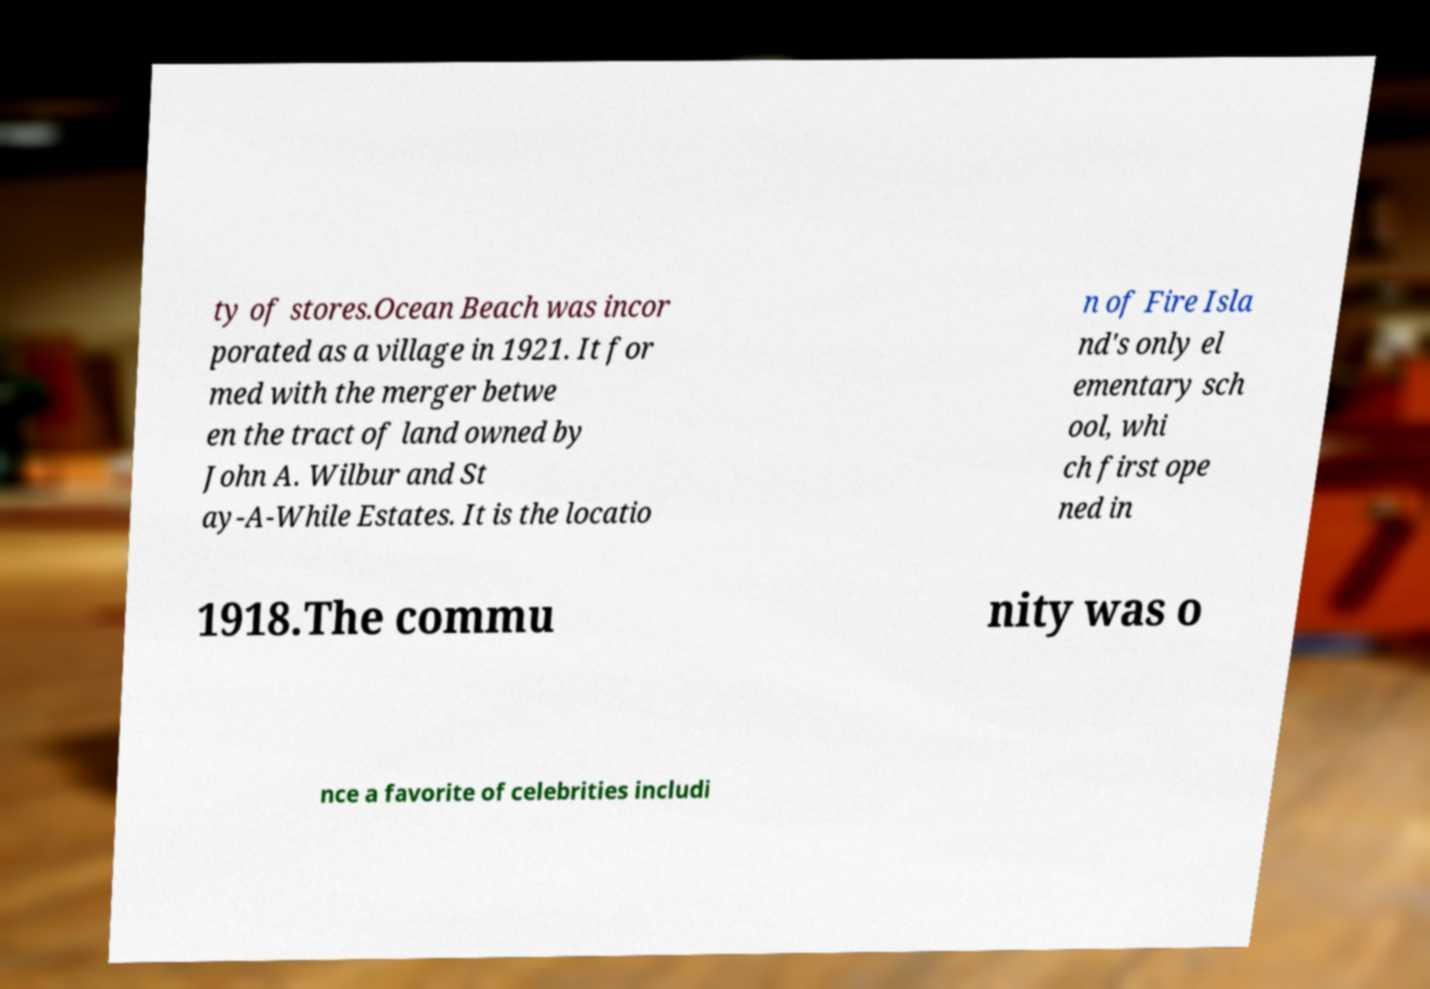Could you assist in decoding the text presented in this image and type it out clearly? ty of stores.Ocean Beach was incor porated as a village in 1921. It for med with the merger betwe en the tract of land owned by John A. Wilbur and St ay-A-While Estates. It is the locatio n of Fire Isla nd's only el ementary sch ool, whi ch first ope ned in 1918.The commu nity was o nce a favorite of celebrities includi 